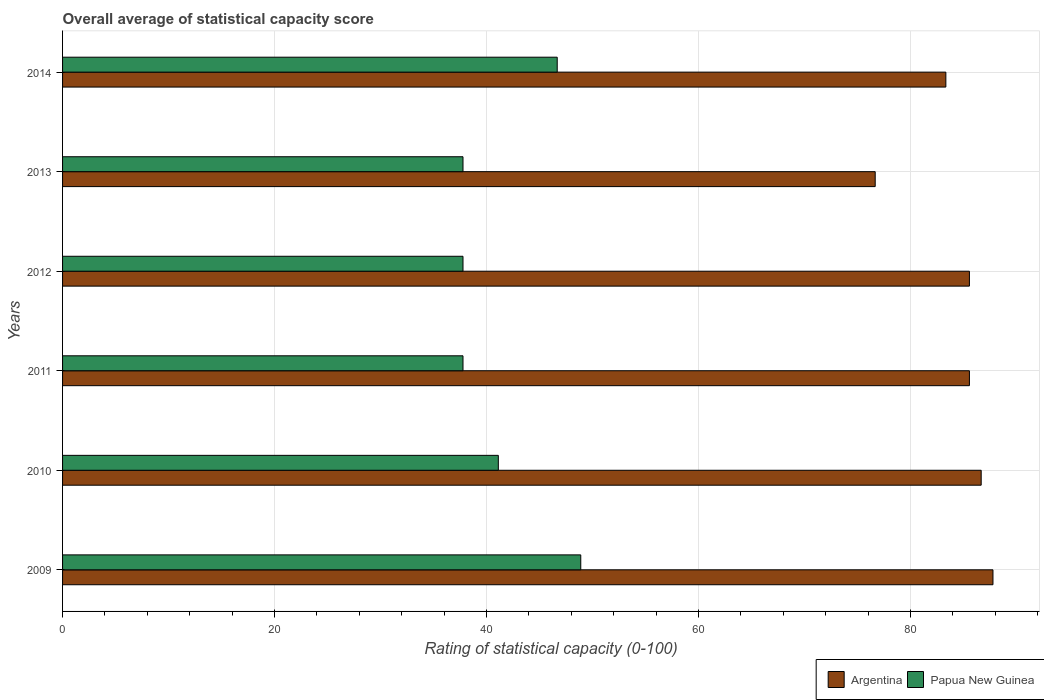How many groups of bars are there?
Your answer should be compact. 6. How many bars are there on the 3rd tick from the top?
Keep it short and to the point. 2. How many bars are there on the 2nd tick from the bottom?
Provide a succinct answer. 2. What is the label of the 6th group of bars from the top?
Provide a short and direct response. 2009. What is the rating of statistical capacity in Papua New Guinea in 2013?
Offer a terse response. 37.78. Across all years, what is the maximum rating of statistical capacity in Papua New Guinea?
Provide a succinct answer. 48.89. Across all years, what is the minimum rating of statistical capacity in Papua New Guinea?
Provide a succinct answer. 37.78. In which year was the rating of statistical capacity in Papua New Guinea minimum?
Offer a very short reply. 2011. What is the total rating of statistical capacity in Papua New Guinea in the graph?
Keep it short and to the point. 250. What is the difference between the rating of statistical capacity in Argentina in 2012 and that in 2013?
Your answer should be compact. 8.89. What is the difference between the rating of statistical capacity in Papua New Guinea in 2009 and the rating of statistical capacity in Argentina in 2014?
Your response must be concise. -34.44. What is the average rating of statistical capacity in Papua New Guinea per year?
Give a very brief answer. 41.67. In the year 2012, what is the difference between the rating of statistical capacity in Argentina and rating of statistical capacity in Papua New Guinea?
Give a very brief answer. 47.78. What is the ratio of the rating of statistical capacity in Papua New Guinea in 2011 to that in 2013?
Offer a terse response. 1. Is the rating of statistical capacity in Argentina in 2009 less than that in 2013?
Offer a terse response. No. Is the difference between the rating of statistical capacity in Argentina in 2009 and 2012 greater than the difference between the rating of statistical capacity in Papua New Guinea in 2009 and 2012?
Provide a short and direct response. No. What is the difference between the highest and the second highest rating of statistical capacity in Papua New Guinea?
Keep it short and to the point. 2.22. What is the difference between the highest and the lowest rating of statistical capacity in Argentina?
Offer a terse response. 11.11. Is the sum of the rating of statistical capacity in Papua New Guinea in 2012 and 2014 greater than the maximum rating of statistical capacity in Argentina across all years?
Make the answer very short. No. What does the 2nd bar from the top in 2014 represents?
Ensure brevity in your answer.  Argentina. What does the 2nd bar from the bottom in 2013 represents?
Keep it short and to the point. Papua New Guinea. How many years are there in the graph?
Provide a short and direct response. 6. What is the difference between two consecutive major ticks on the X-axis?
Offer a terse response. 20. Are the values on the major ticks of X-axis written in scientific E-notation?
Offer a very short reply. No. How many legend labels are there?
Ensure brevity in your answer.  2. How are the legend labels stacked?
Your answer should be compact. Horizontal. What is the title of the graph?
Provide a short and direct response. Overall average of statistical capacity score. Does "Latvia" appear as one of the legend labels in the graph?
Make the answer very short. No. What is the label or title of the X-axis?
Your answer should be compact. Rating of statistical capacity (0-100). What is the label or title of the Y-axis?
Your answer should be compact. Years. What is the Rating of statistical capacity (0-100) in Argentina in 2009?
Make the answer very short. 87.78. What is the Rating of statistical capacity (0-100) of Papua New Guinea in 2009?
Offer a terse response. 48.89. What is the Rating of statistical capacity (0-100) of Argentina in 2010?
Keep it short and to the point. 86.67. What is the Rating of statistical capacity (0-100) of Papua New Guinea in 2010?
Provide a short and direct response. 41.11. What is the Rating of statistical capacity (0-100) of Argentina in 2011?
Ensure brevity in your answer.  85.56. What is the Rating of statistical capacity (0-100) in Papua New Guinea in 2011?
Your response must be concise. 37.78. What is the Rating of statistical capacity (0-100) in Argentina in 2012?
Offer a very short reply. 85.56. What is the Rating of statistical capacity (0-100) of Papua New Guinea in 2012?
Your answer should be very brief. 37.78. What is the Rating of statistical capacity (0-100) of Argentina in 2013?
Make the answer very short. 76.67. What is the Rating of statistical capacity (0-100) of Papua New Guinea in 2013?
Ensure brevity in your answer.  37.78. What is the Rating of statistical capacity (0-100) of Argentina in 2014?
Your response must be concise. 83.33. What is the Rating of statistical capacity (0-100) of Papua New Guinea in 2014?
Make the answer very short. 46.67. Across all years, what is the maximum Rating of statistical capacity (0-100) of Argentina?
Ensure brevity in your answer.  87.78. Across all years, what is the maximum Rating of statistical capacity (0-100) in Papua New Guinea?
Keep it short and to the point. 48.89. Across all years, what is the minimum Rating of statistical capacity (0-100) in Argentina?
Provide a short and direct response. 76.67. Across all years, what is the minimum Rating of statistical capacity (0-100) in Papua New Guinea?
Make the answer very short. 37.78. What is the total Rating of statistical capacity (0-100) in Argentina in the graph?
Make the answer very short. 505.56. What is the total Rating of statistical capacity (0-100) of Papua New Guinea in the graph?
Your response must be concise. 250. What is the difference between the Rating of statistical capacity (0-100) of Papua New Guinea in 2009 and that in 2010?
Your response must be concise. 7.78. What is the difference between the Rating of statistical capacity (0-100) of Argentina in 2009 and that in 2011?
Make the answer very short. 2.22. What is the difference between the Rating of statistical capacity (0-100) in Papua New Guinea in 2009 and that in 2011?
Provide a short and direct response. 11.11. What is the difference between the Rating of statistical capacity (0-100) in Argentina in 2009 and that in 2012?
Give a very brief answer. 2.22. What is the difference between the Rating of statistical capacity (0-100) of Papua New Guinea in 2009 and that in 2012?
Offer a very short reply. 11.11. What is the difference between the Rating of statistical capacity (0-100) in Argentina in 2009 and that in 2013?
Make the answer very short. 11.11. What is the difference between the Rating of statistical capacity (0-100) in Papua New Guinea in 2009 and that in 2013?
Give a very brief answer. 11.11. What is the difference between the Rating of statistical capacity (0-100) in Argentina in 2009 and that in 2014?
Ensure brevity in your answer.  4.44. What is the difference between the Rating of statistical capacity (0-100) in Papua New Guinea in 2009 and that in 2014?
Offer a very short reply. 2.22. What is the difference between the Rating of statistical capacity (0-100) of Papua New Guinea in 2010 and that in 2011?
Keep it short and to the point. 3.33. What is the difference between the Rating of statistical capacity (0-100) in Argentina in 2010 and that in 2012?
Your response must be concise. 1.11. What is the difference between the Rating of statistical capacity (0-100) of Argentina in 2010 and that in 2013?
Your answer should be compact. 10. What is the difference between the Rating of statistical capacity (0-100) in Argentina in 2010 and that in 2014?
Ensure brevity in your answer.  3.33. What is the difference between the Rating of statistical capacity (0-100) of Papua New Guinea in 2010 and that in 2014?
Provide a short and direct response. -5.56. What is the difference between the Rating of statistical capacity (0-100) in Papua New Guinea in 2011 and that in 2012?
Offer a terse response. 0. What is the difference between the Rating of statistical capacity (0-100) in Argentina in 2011 and that in 2013?
Your answer should be compact. 8.89. What is the difference between the Rating of statistical capacity (0-100) of Papua New Guinea in 2011 and that in 2013?
Your response must be concise. 0. What is the difference between the Rating of statistical capacity (0-100) of Argentina in 2011 and that in 2014?
Ensure brevity in your answer.  2.22. What is the difference between the Rating of statistical capacity (0-100) in Papua New Guinea in 2011 and that in 2014?
Ensure brevity in your answer.  -8.89. What is the difference between the Rating of statistical capacity (0-100) in Argentina in 2012 and that in 2013?
Keep it short and to the point. 8.89. What is the difference between the Rating of statistical capacity (0-100) in Papua New Guinea in 2012 and that in 2013?
Provide a short and direct response. 0. What is the difference between the Rating of statistical capacity (0-100) of Argentina in 2012 and that in 2014?
Your response must be concise. 2.22. What is the difference between the Rating of statistical capacity (0-100) in Papua New Guinea in 2012 and that in 2014?
Offer a terse response. -8.89. What is the difference between the Rating of statistical capacity (0-100) of Argentina in 2013 and that in 2014?
Provide a short and direct response. -6.67. What is the difference between the Rating of statistical capacity (0-100) in Papua New Guinea in 2013 and that in 2014?
Make the answer very short. -8.89. What is the difference between the Rating of statistical capacity (0-100) of Argentina in 2009 and the Rating of statistical capacity (0-100) of Papua New Guinea in 2010?
Offer a very short reply. 46.67. What is the difference between the Rating of statistical capacity (0-100) of Argentina in 2009 and the Rating of statistical capacity (0-100) of Papua New Guinea in 2011?
Your response must be concise. 50. What is the difference between the Rating of statistical capacity (0-100) in Argentina in 2009 and the Rating of statistical capacity (0-100) in Papua New Guinea in 2014?
Give a very brief answer. 41.11. What is the difference between the Rating of statistical capacity (0-100) of Argentina in 2010 and the Rating of statistical capacity (0-100) of Papua New Guinea in 2011?
Ensure brevity in your answer.  48.89. What is the difference between the Rating of statistical capacity (0-100) in Argentina in 2010 and the Rating of statistical capacity (0-100) in Papua New Guinea in 2012?
Your answer should be compact. 48.89. What is the difference between the Rating of statistical capacity (0-100) in Argentina in 2010 and the Rating of statistical capacity (0-100) in Papua New Guinea in 2013?
Ensure brevity in your answer.  48.89. What is the difference between the Rating of statistical capacity (0-100) in Argentina in 2010 and the Rating of statistical capacity (0-100) in Papua New Guinea in 2014?
Give a very brief answer. 40. What is the difference between the Rating of statistical capacity (0-100) in Argentina in 2011 and the Rating of statistical capacity (0-100) in Papua New Guinea in 2012?
Provide a succinct answer. 47.78. What is the difference between the Rating of statistical capacity (0-100) in Argentina in 2011 and the Rating of statistical capacity (0-100) in Papua New Guinea in 2013?
Make the answer very short. 47.78. What is the difference between the Rating of statistical capacity (0-100) in Argentina in 2011 and the Rating of statistical capacity (0-100) in Papua New Guinea in 2014?
Your answer should be very brief. 38.89. What is the difference between the Rating of statistical capacity (0-100) in Argentina in 2012 and the Rating of statistical capacity (0-100) in Papua New Guinea in 2013?
Your response must be concise. 47.78. What is the difference between the Rating of statistical capacity (0-100) in Argentina in 2012 and the Rating of statistical capacity (0-100) in Papua New Guinea in 2014?
Give a very brief answer. 38.89. What is the difference between the Rating of statistical capacity (0-100) of Argentina in 2013 and the Rating of statistical capacity (0-100) of Papua New Guinea in 2014?
Provide a succinct answer. 30. What is the average Rating of statistical capacity (0-100) in Argentina per year?
Your response must be concise. 84.26. What is the average Rating of statistical capacity (0-100) in Papua New Guinea per year?
Provide a succinct answer. 41.67. In the year 2009, what is the difference between the Rating of statistical capacity (0-100) of Argentina and Rating of statistical capacity (0-100) of Papua New Guinea?
Keep it short and to the point. 38.89. In the year 2010, what is the difference between the Rating of statistical capacity (0-100) in Argentina and Rating of statistical capacity (0-100) in Papua New Guinea?
Your answer should be compact. 45.56. In the year 2011, what is the difference between the Rating of statistical capacity (0-100) of Argentina and Rating of statistical capacity (0-100) of Papua New Guinea?
Make the answer very short. 47.78. In the year 2012, what is the difference between the Rating of statistical capacity (0-100) of Argentina and Rating of statistical capacity (0-100) of Papua New Guinea?
Make the answer very short. 47.78. In the year 2013, what is the difference between the Rating of statistical capacity (0-100) of Argentina and Rating of statistical capacity (0-100) of Papua New Guinea?
Offer a terse response. 38.89. In the year 2014, what is the difference between the Rating of statistical capacity (0-100) of Argentina and Rating of statistical capacity (0-100) of Papua New Guinea?
Keep it short and to the point. 36.67. What is the ratio of the Rating of statistical capacity (0-100) of Argentina in 2009 to that in 2010?
Give a very brief answer. 1.01. What is the ratio of the Rating of statistical capacity (0-100) of Papua New Guinea in 2009 to that in 2010?
Ensure brevity in your answer.  1.19. What is the ratio of the Rating of statistical capacity (0-100) in Papua New Guinea in 2009 to that in 2011?
Your answer should be very brief. 1.29. What is the ratio of the Rating of statistical capacity (0-100) in Papua New Guinea in 2009 to that in 2012?
Provide a short and direct response. 1.29. What is the ratio of the Rating of statistical capacity (0-100) of Argentina in 2009 to that in 2013?
Your answer should be very brief. 1.14. What is the ratio of the Rating of statistical capacity (0-100) in Papua New Guinea in 2009 to that in 2013?
Ensure brevity in your answer.  1.29. What is the ratio of the Rating of statistical capacity (0-100) of Argentina in 2009 to that in 2014?
Give a very brief answer. 1.05. What is the ratio of the Rating of statistical capacity (0-100) of Papua New Guinea in 2009 to that in 2014?
Provide a short and direct response. 1.05. What is the ratio of the Rating of statistical capacity (0-100) of Papua New Guinea in 2010 to that in 2011?
Your answer should be compact. 1.09. What is the ratio of the Rating of statistical capacity (0-100) in Argentina in 2010 to that in 2012?
Your response must be concise. 1.01. What is the ratio of the Rating of statistical capacity (0-100) in Papua New Guinea in 2010 to that in 2012?
Offer a very short reply. 1.09. What is the ratio of the Rating of statistical capacity (0-100) in Argentina in 2010 to that in 2013?
Provide a succinct answer. 1.13. What is the ratio of the Rating of statistical capacity (0-100) of Papua New Guinea in 2010 to that in 2013?
Your answer should be compact. 1.09. What is the ratio of the Rating of statistical capacity (0-100) of Argentina in 2010 to that in 2014?
Give a very brief answer. 1.04. What is the ratio of the Rating of statistical capacity (0-100) in Papua New Guinea in 2010 to that in 2014?
Give a very brief answer. 0.88. What is the ratio of the Rating of statistical capacity (0-100) in Papua New Guinea in 2011 to that in 2012?
Provide a short and direct response. 1. What is the ratio of the Rating of statistical capacity (0-100) in Argentina in 2011 to that in 2013?
Offer a very short reply. 1.12. What is the ratio of the Rating of statistical capacity (0-100) of Argentina in 2011 to that in 2014?
Your answer should be very brief. 1.03. What is the ratio of the Rating of statistical capacity (0-100) in Papua New Guinea in 2011 to that in 2014?
Offer a very short reply. 0.81. What is the ratio of the Rating of statistical capacity (0-100) in Argentina in 2012 to that in 2013?
Provide a short and direct response. 1.12. What is the ratio of the Rating of statistical capacity (0-100) in Argentina in 2012 to that in 2014?
Your answer should be very brief. 1.03. What is the ratio of the Rating of statistical capacity (0-100) in Papua New Guinea in 2012 to that in 2014?
Ensure brevity in your answer.  0.81. What is the ratio of the Rating of statistical capacity (0-100) in Papua New Guinea in 2013 to that in 2014?
Your answer should be very brief. 0.81. What is the difference between the highest and the second highest Rating of statistical capacity (0-100) of Papua New Guinea?
Your answer should be very brief. 2.22. What is the difference between the highest and the lowest Rating of statistical capacity (0-100) in Argentina?
Make the answer very short. 11.11. What is the difference between the highest and the lowest Rating of statistical capacity (0-100) in Papua New Guinea?
Give a very brief answer. 11.11. 